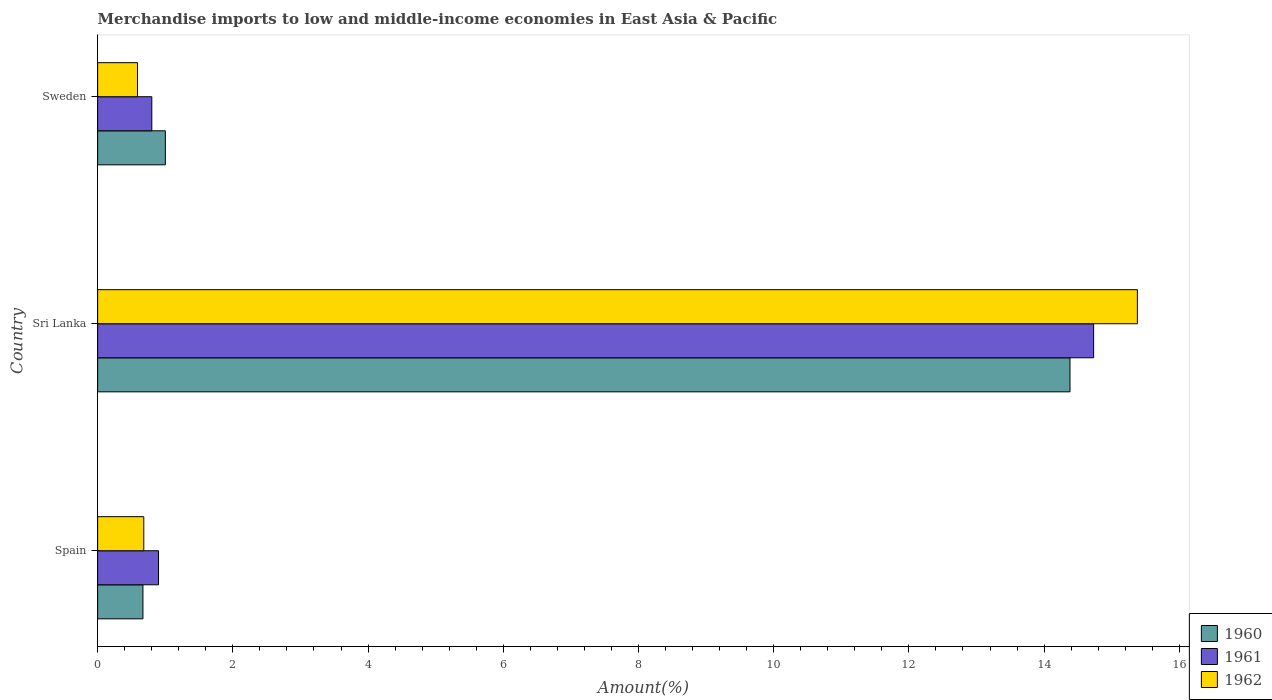How many different coloured bars are there?
Your answer should be compact. 3. How many bars are there on the 3rd tick from the top?
Ensure brevity in your answer.  3. What is the percentage of amount earned from merchandise imports in 1961 in Sweden?
Your response must be concise. 0.8. Across all countries, what is the maximum percentage of amount earned from merchandise imports in 1961?
Provide a short and direct response. 14.73. Across all countries, what is the minimum percentage of amount earned from merchandise imports in 1961?
Keep it short and to the point. 0.8. In which country was the percentage of amount earned from merchandise imports in 1961 maximum?
Provide a short and direct response. Sri Lanka. In which country was the percentage of amount earned from merchandise imports in 1961 minimum?
Keep it short and to the point. Sweden. What is the total percentage of amount earned from merchandise imports in 1961 in the graph?
Your answer should be very brief. 16.44. What is the difference between the percentage of amount earned from merchandise imports in 1960 in Spain and that in Sri Lanka?
Make the answer very short. -13.71. What is the difference between the percentage of amount earned from merchandise imports in 1962 in Sri Lanka and the percentage of amount earned from merchandise imports in 1961 in Spain?
Your answer should be very brief. 14.48. What is the average percentage of amount earned from merchandise imports in 1962 per country?
Give a very brief answer. 5.55. What is the difference between the percentage of amount earned from merchandise imports in 1960 and percentage of amount earned from merchandise imports in 1962 in Sweden?
Ensure brevity in your answer.  0.41. What is the ratio of the percentage of amount earned from merchandise imports in 1960 in Sri Lanka to that in Sweden?
Your answer should be very brief. 14.36. What is the difference between the highest and the second highest percentage of amount earned from merchandise imports in 1961?
Provide a succinct answer. 13.83. What is the difference between the highest and the lowest percentage of amount earned from merchandise imports in 1962?
Ensure brevity in your answer.  14.79. Is the sum of the percentage of amount earned from merchandise imports in 1962 in Sri Lanka and Sweden greater than the maximum percentage of amount earned from merchandise imports in 1961 across all countries?
Your answer should be compact. Yes. What does the 2nd bar from the bottom in Sri Lanka represents?
Make the answer very short. 1961. Is it the case that in every country, the sum of the percentage of amount earned from merchandise imports in 1960 and percentage of amount earned from merchandise imports in 1961 is greater than the percentage of amount earned from merchandise imports in 1962?
Your answer should be compact. Yes. How many bars are there?
Provide a short and direct response. 9. How many countries are there in the graph?
Your answer should be compact. 3. What is the difference between two consecutive major ticks on the X-axis?
Ensure brevity in your answer.  2. Does the graph contain grids?
Provide a short and direct response. No. Where does the legend appear in the graph?
Your response must be concise. Bottom right. What is the title of the graph?
Your answer should be compact. Merchandise imports to low and middle-income economies in East Asia & Pacific. Does "1986" appear as one of the legend labels in the graph?
Offer a terse response. No. What is the label or title of the X-axis?
Provide a succinct answer. Amount(%). What is the Amount(%) in 1960 in Spain?
Provide a succinct answer. 0.67. What is the Amount(%) in 1961 in Spain?
Provide a short and direct response. 0.9. What is the Amount(%) of 1962 in Spain?
Provide a succinct answer. 0.68. What is the Amount(%) in 1960 in Sri Lanka?
Your response must be concise. 14.38. What is the Amount(%) in 1961 in Sri Lanka?
Ensure brevity in your answer.  14.73. What is the Amount(%) in 1962 in Sri Lanka?
Ensure brevity in your answer.  15.38. What is the Amount(%) in 1960 in Sweden?
Provide a succinct answer. 1. What is the Amount(%) in 1961 in Sweden?
Provide a short and direct response. 0.8. What is the Amount(%) of 1962 in Sweden?
Provide a short and direct response. 0.59. Across all countries, what is the maximum Amount(%) of 1960?
Make the answer very short. 14.38. Across all countries, what is the maximum Amount(%) in 1961?
Ensure brevity in your answer.  14.73. Across all countries, what is the maximum Amount(%) of 1962?
Keep it short and to the point. 15.38. Across all countries, what is the minimum Amount(%) of 1960?
Your answer should be compact. 0.67. Across all countries, what is the minimum Amount(%) of 1961?
Your answer should be compact. 0.8. Across all countries, what is the minimum Amount(%) in 1962?
Provide a succinct answer. 0.59. What is the total Amount(%) in 1960 in the graph?
Make the answer very short. 16.06. What is the total Amount(%) of 1961 in the graph?
Keep it short and to the point. 16.44. What is the total Amount(%) of 1962 in the graph?
Your answer should be very brief. 16.65. What is the difference between the Amount(%) in 1960 in Spain and that in Sri Lanka?
Offer a terse response. -13.71. What is the difference between the Amount(%) in 1961 in Spain and that in Sri Lanka?
Provide a short and direct response. -13.83. What is the difference between the Amount(%) in 1962 in Spain and that in Sri Lanka?
Your answer should be compact. -14.7. What is the difference between the Amount(%) in 1960 in Spain and that in Sweden?
Your response must be concise. -0.33. What is the difference between the Amount(%) in 1961 in Spain and that in Sweden?
Keep it short and to the point. 0.1. What is the difference between the Amount(%) of 1962 in Spain and that in Sweden?
Your answer should be compact. 0.09. What is the difference between the Amount(%) of 1960 in Sri Lanka and that in Sweden?
Make the answer very short. 13.38. What is the difference between the Amount(%) in 1961 in Sri Lanka and that in Sweden?
Your response must be concise. 13.93. What is the difference between the Amount(%) in 1962 in Sri Lanka and that in Sweden?
Give a very brief answer. 14.79. What is the difference between the Amount(%) of 1960 in Spain and the Amount(%) of 1961 in Sri Lanka?
Your response must be concise. -14.06. What is the difference between the Amount(%) of 1960 in Spain and the Amount(%) of 1962 in Sri Lanka?
Make the answer very short. -14.71. What is the difference between the Amount(%) in 1961 in Spain and the Amount(%) in 1962 in Sri Lanka?
Give a very brief answer. -14.48. What is the difference between the Amount(%) in 1960 in Spain and the Amount(%) in 1961 in Sweden?
Your response must be concise. -0.13. What is the difference between the Amount(%) in 1960 in Spain and the Amount(%) in 1962 in Sweden?
Make the answer very short. 0.08. What is the difference between the Amount(%) of 1961 in Spain and the Amount(%) of 1962 in Sweden?
Provide a succinct answer. 0.31. What is the difference between the Amount(%) of 1960 in Sri Lanka and the Amount(%) of 1961 in Sweden?
Your response must be concise. 13.58. What is the difference between the Amount(%) of 1960 in Sri Lanka and the Amount(%) of 1962 in Sweden?
Provide a short and direct response. 13.79. What is the difference between the Amount(%) in 1961 in Sri Lanka and the Amount(%) in 1962 in Sweden?
Your answer should be compact. 14.14. What is the average Amount(%) in 1960 per country?
Ensure brevity in your answer.  5.35. What is the average Amount(%) of 1961 per country?
Your answer should be very brief. 5.48. What is the average Amount(%) in 1962 per country?
Provide a short and direct response. 5.55. What is the difference between the Amount(%) in 1960 and Amount(%) in 1961 in Spain?
Your answer should be compact. -0.23. What is the difference between the Amount(%) of 1960 and Amount(%) of 1962 in Spain?
Give a very brief answer. -0.01. What is the difference between the Amount(%) in 1961 and Amount(%) in 1962 in Spain?
Your answer should be very brief. 0.22. What is the difference between the Amount(%) of 1960 and Amount(%) of 1961 in Sri Lanka?
Your answer should be very brief. -0.35. What is the difference between the Amount(%) of 1960 and Amount(%) of 1962 in Sri Lanka?
Provide a succinct answer. -1. What is the difference between the Amount(%) in 1961 and Amount(%) in 1962 in Sri Lanka?
Provide a succinct answer. -0.65. What is the difference between the Amount(%) in 1960 and Amount(%) in 1961 in Sweden?
Give a very brief answer. 0.2. What is the difference between the Amount(%) in 1960 and Amount(%) in 1962 in Sweden?
Provide a short and direct response. 0.41. What is the difference between the Amount(%) of 1961 and Amount(%) of 1962 in Sweden?
Provide a short and direct response. 0.21. What is the ratio of the Amount(%) in 1960 in Spain to that in Sri Lanka?
Make the answer very short. 0.05. What is the ratio of the Amount(%) in 1961 in Spain to that in Sri Lanka?
Offer a very short reply. 0.06. What is the ratio of the Amount(%) in 1962 in Spain to that in Sri Lanka?
Offer a terse response. 0.04. What is the ratio of the Amount(%) in 1960 in Spain to that in Sweden?
Ensure brevity in your answer.  0.67. What is the ratio of the Amount(%) in 1961 in Spain to that in Sweden?
Your answer should be compact. 1.12. What is the ratio of the Amount(%) of 1962 in Spain to that in Sweden?
Make the answer very short. 1.16. What is the ratio of the Amount(%) in 1960 in Sri Lanka to that in Sweden?
Provide a short and direct response. 14.36. What is the ratio of the Amount(%) in 1961 in Sri Lanka to that in Sweden?
Make the answer very short. 18.38. What is the ratio of the Amount(%) of 1962 in Sri Lanka to that in Sweden?
Your response must be concise. 26.07. What is the difference between the highest and the second highest Amount(%) of 1960?
Offer a very short reply. 13.38. What is the difference between the highest and the second highest Amount(%) of 1961?
Offer a very short reply. 13.83. What is the difference between the highest and the second highest Amount(%) in 1962?
Your response must be concise. 14.7. What is the difference between the highest and the lowest Amount(%) in 1960?
Keep it short and to the point. 13.71. What is the difference between the highest and the lowest Amount(%) of 1961?
Ensure brevity in your answer.  13.93. What is the difference between the highest and the lowest Amount(%) in 1962?
Offer a very short reply. 14.79. 